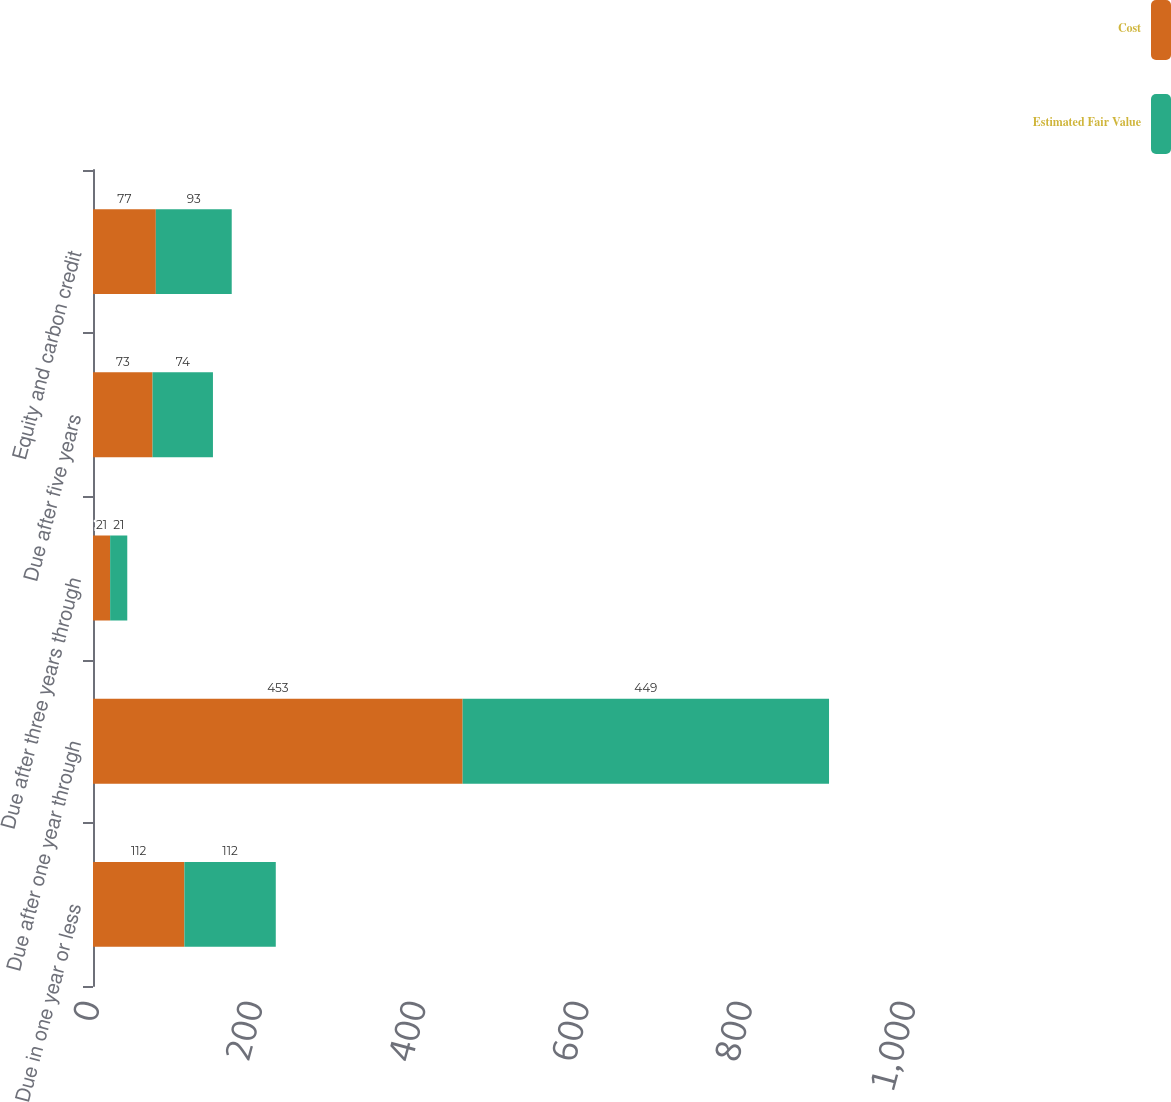Convert chart to OTSL. <chart><loc_0><loc_0><loc_500><loc_500><stacked_bar_chart><ecel><fcel>Due in one year or less<fcel>Due after one year through<fcel>Due after three years through<fcel>Due after five years<fcel>Equity and carbon credit<nl><fcel>Cost<fcel>112<fcel>453<fcel>21<fcel>73<fcel>77<nl><fcel>Estimated Fair Value<fcel>112<fcel>449<fcel>21<fcel>74<fcel>93<nl></chart> 